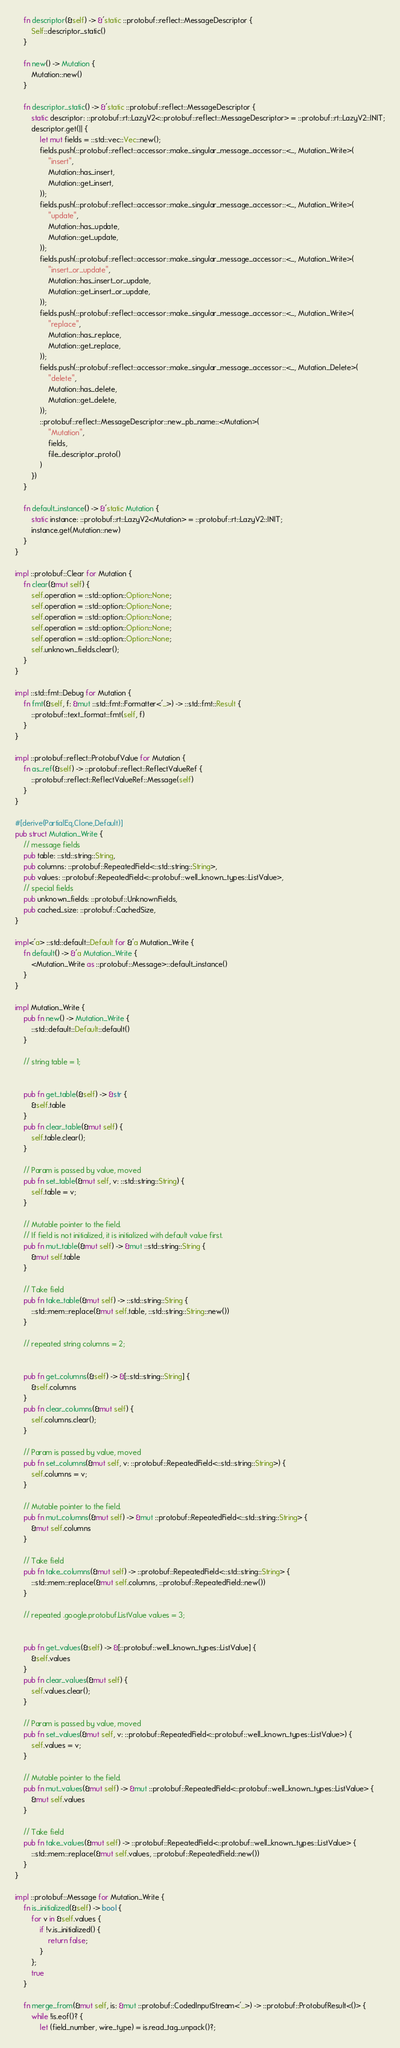Convert code to text. <code><loc_0><loc_0><loc_500><loc_500><_Rust_>
    fn descriptor(&self) -> &'static ::protobuf::reflect::MessageDescriptor {
        Self::descriptor_static()
    }

    fn new() -> Mutation {
        Mutation::new()
    }

    fn descriptor_static() -> &'static ::protobuf::reflect::MessageDescriptor {
        static descriptor: ::protobuf::rt::LazyV2<::protobuf::reflect::MessageDescriptor> = ::protobuf::rt::LazyV2::INIT;
        descriptor.get(|| {
            let mut fields = ::std::vec::Vec::new();
            fields.push(::protobuf::reflect::accessor::make_singular_message_accessor::<_, Mutation_Write>(
                "insert",
                Mutation::has_insert,
                Mutation::get_insert,
            ));
            fields.push(::protobuf::reflect::accessor::make_singular_message_accessor::<_, Mutation_Write>(
                "update",
                Mutation::has_update,
                Mutation::get_update,
            ));
            fields.push(::protobuf::reflect::accessor::make_singular_message_accessor::<_, Mutation_Write>(
                "insert_or_update",
                Mutation::has_insert_or_update,
                Mutation::get_insert_or_update,
            ));
            fields.push(::protobuf::reflect::accessor::make_singular_message_accessor::<_, Mutation_Write>(
                "replace",
                Mutation::has_replace,
                Mutation::get_replace,
            ));
            fields.push(::protobuf::reflect::accessor::make_singular_message_accessor::<_, Mutation_Delete>(
                "delete",
                Mutation::has_delete,
                Mutation::get_delete,
            ));
            ::protobuf::reflect::MessageDescriptor::new_pb_name::<Mutation>(
                "Mutation",
                fields,
                file_descriptor_proto()
            )
        })
    }

    fn default_instance() -> &'static Mutation {
        static instance: ::protobuf::rt::LazyV2<Mutation> = ::protobuf::rt::LazyV2::INIT;
        instance.get(Mutation::new)
    }
}

impl ::protobuf::Clear for Mutation {
    fn clear(&mut self) {
        self.operation = ::std::option::Option::None;
        self.operation = ::std::option::Option::None;
        self.operation = ::std::option::Option::None;
        self.operation = ::std::option::Option::None;
        self.operation = ::std::option::Option::None;
        self.unknown_fields.clear();
    }
}

impl ::std::fmt::Debug for Mutation {
    fn fmt(&self, f: &mut ::std::fmt::Formatter<'_>) -> ::std::fmt::Result {
        ::protobuf::text_format::fmt(self, f)
    }
}

impl ::protobuf::reflect::ProtobufValue for Mutation {
    fn as_ref(&self) -> ::protobuf::reflect::ReflectValueRef {
        ::protobuf::reflect::ReflectValueRef::Message(self)
    }
}

#[derive(PartialEq,Clone,Default)]
pub struct Mutation_Write {
    // message fields
    pub table: ::std::string::String,
    pub columns: ::protobuf::RepeatedField<::std::string::String>,
    pub values: ::protobuf::RepeatedField<::protobuf::well_known_types::ListValue>,
    // special fields
    pub unknown_fields: ::protobuf::UnknownFields,
    pub cached_size: ::protobuf::CachedSize,
}

impl<'a> ::std::default::Default for &'a Mutation_Write {
    fn default() -> &'a Mutation_Write {
        <Mutation_Write as ::protobuf::Message>::default_instance()
    }
}

impl Mutation_Write {
    pub fn new() -> Mutation_Write {
        ::std::default::Default::default()
    }

    // string table = 1;


    pub fn get_table(&self) -> &str {
        &self.table
    }
    pub fn clear_table(&mut self) {
        self.table.clear();
    }

    // Param is passed by value, moved
    pub fn set_table(&mut self, v: ::std::string::String) {
        self.table = v;
    }

    // Mutable pointer to the field.
    // If field is not initialized, it is initialized with default value first.
    pub fn mut_table(&mut self) -> &mut ::std::string::String {
        &mut self.table
    }

    // Take field
    pub fn take_table(&mut self) -> ::std::string::String {
        ::std::mem::replace(&mut self.table, ::std::string::String::new())
    }

    // repeated string columns = 2;


    pub fn get_columns(&self) -> &[::std::string::String] {
        &self.columns
    }
    pub fn clear_columns(&mut self) {
        self.columns.clear();
    }

    // Param is passed by value, moved
    pub fn set_columns(&mut self, v: ::protobuf::RepeatedField<::std::string::String>) {
        self.columns = v;
    }

    // Mutable pointer to the field.
    pub fn mut_columns(&mut self) -> &mut ::protobuf::RepeatedField<::std::string::String> {
        &mut self.columns
    }

    // Take field
    pub fn take_columns(&mut self) -> ::protobuf::RepeatedField<::std::string::String> {
        ::std::mem::replace(&mut self.columns, ::protobuf::RepeatedField::new())
    }

    // repeated .google.protobuf.ListValue values = 3;


    pub fn get_values(&self) -> &[::protobuf::well_known_types::ListValue] {
        &self.values
    }
    pub fn clear_values(&mut self) {
        self.values.clear();
    }

    // Param is passed by value, moved
    pub fn set_values(&mut self, v: ::protobuf::RepeatedField<::protobuf::well_known_types::ListValue>) {
        self.values = v;
    }

    // Mutable pointer to the field.
    pub fn mut_values(&mut self) -> &mut ::protobuf::RepeatedField<::protobuf::well_known_types::ListValue> {
        &mut self.values
    }

    // Take field
    pub fn take_values(&mut self) -> ::protobuf::RepeatedField<::protobuf::well_known_types::ListValue> {
        ::std::mem::replace(&mut self.values, ::protobuf::RepeatedField::new())
    }
}

impl ::protobuf::Message for Mutation_Write {
    fn is_initialized(&self) -> bool {
        for v in &self.values {
            if !v.is_initialized() {
                return false;
            }
        };
        true
    }

    fn merge_from(&mut self, is: &mut ::protobuf::CodedInputStream<'_>) -> ::protobuf::ProtobufResult<()> {
        while !is.eof()? {
            let (field_number, wire_type) = is.read_tag_unpack()?;</code> 